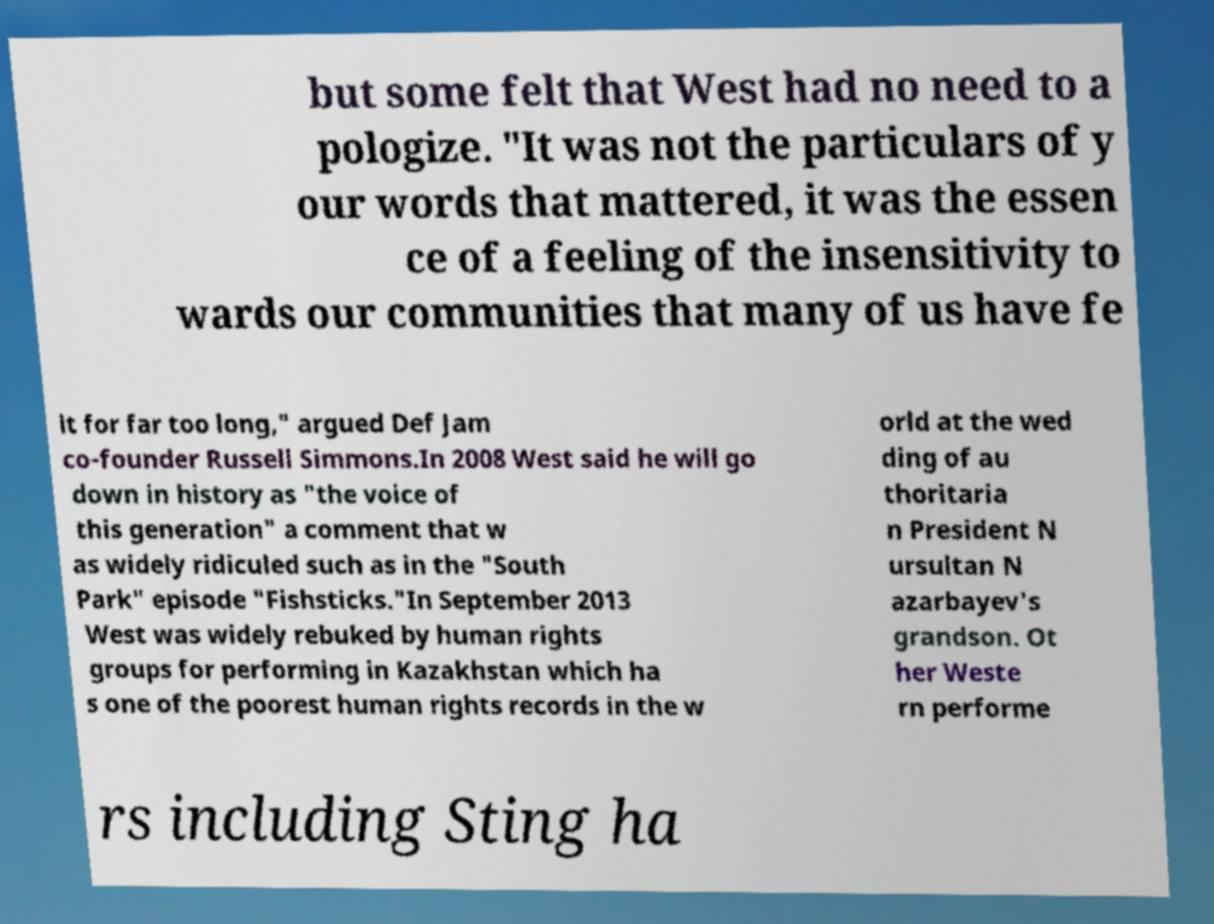Please read and relay the text visible in this image. What does it say? but some felt that West had no need to a pologize. "It was not the particulars of y our words that mattered, it was the essen ce of a feeling of the insensitivity to wards our communities that many of us have fe lt for far too long," argued Def Jam co-founder Russell Simmons.In 2008 West said he will go down in history as "the voice of this generation" a comment that w as widely ridiculed such as in the "South Park" episode "Fishsticks."In September 2013 West was widely rebuked by human rights groups for performing in Kazakhstan which ha s one of the poorest human rights records in the w orld at the wed ding of au thoritaria n President N ursultan N azarbayev's grandson. Ot her Weste rn performe rs including Sting ha 